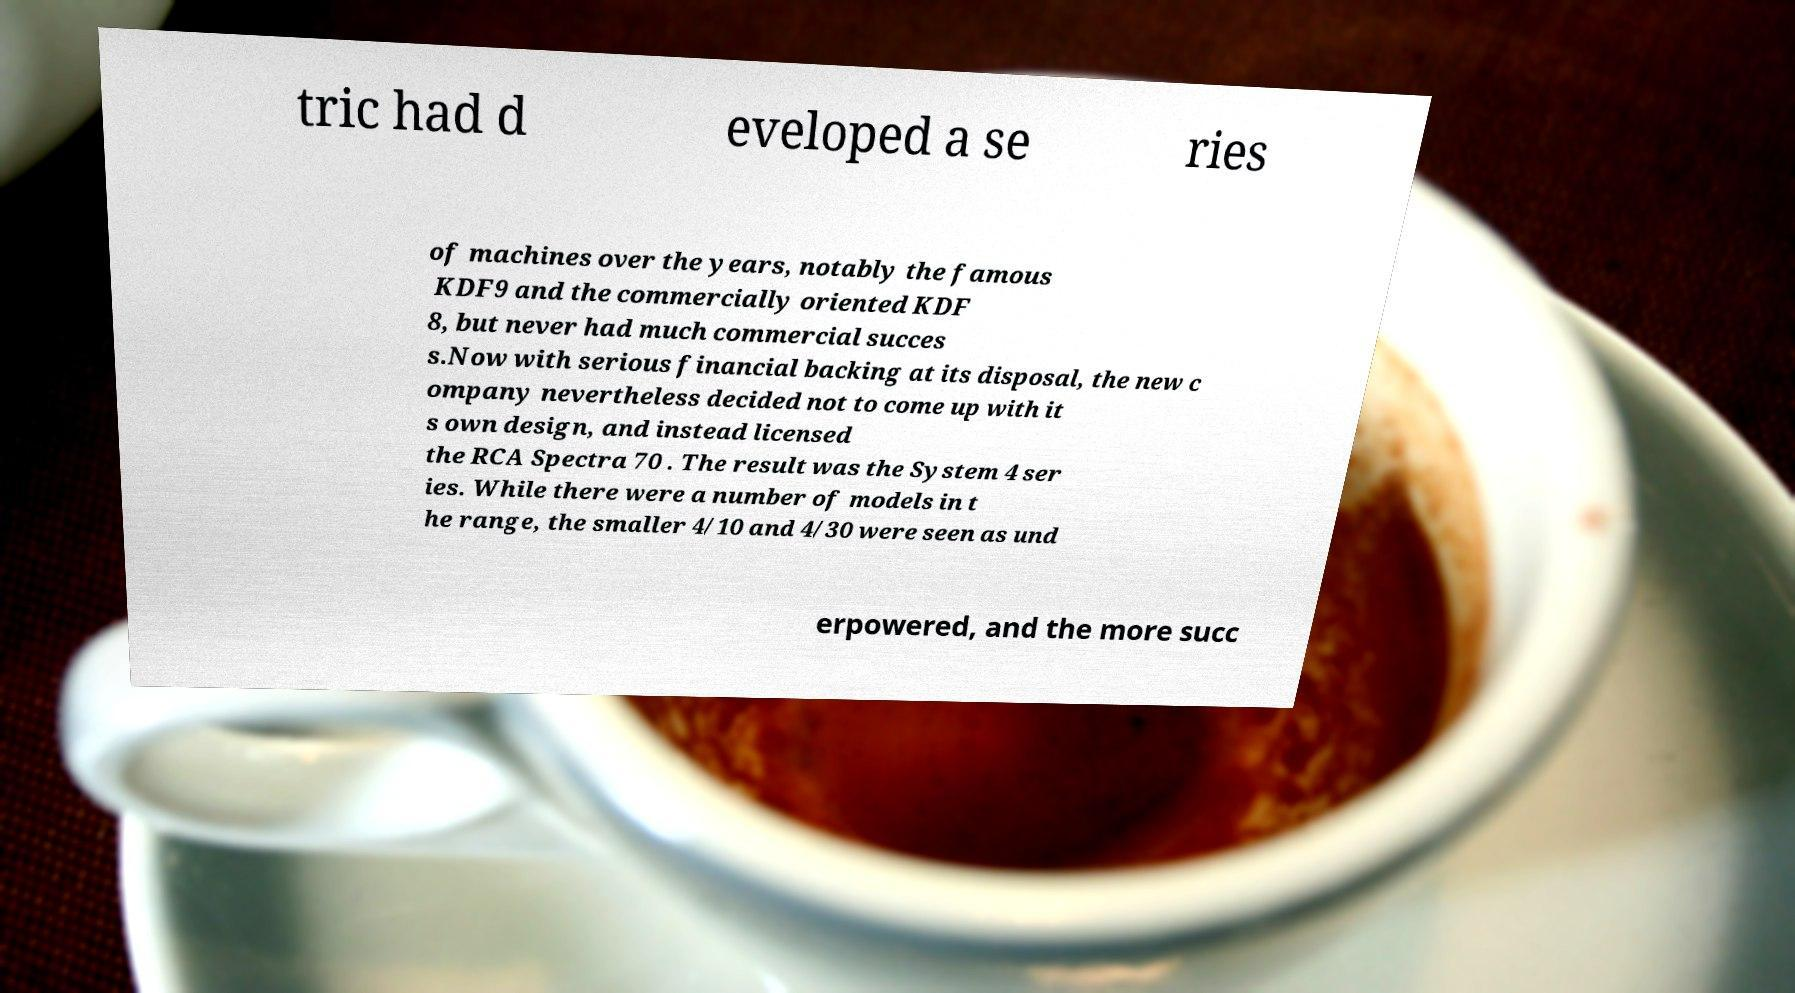What messages or text are displayed in this image? I need them in a readable, typed format. tric had d eveloped a se ries of machines over the years, notably the famous KDF9 and the commercially oriented KDF 8, but never had much commercial succes s.Now with serious financial backing at its disposal, the new c ompany nevertheless decided not to come up with it s own design, and instead licensed the RCA Spectra 70 . The result was the System 4 ser ies. While there were a number of models in t he range, the smaller 4/10 and 4/30 were seen as und erpowered, and the more succ 